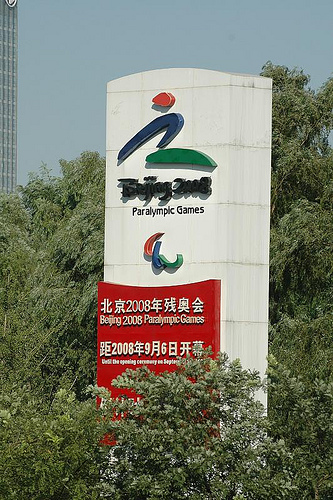<image>
Is there a wall behind the tree? No. The wall is not behind the tree. From this viewpoint, the wall appears to be positioned elsewhere in the scene. 